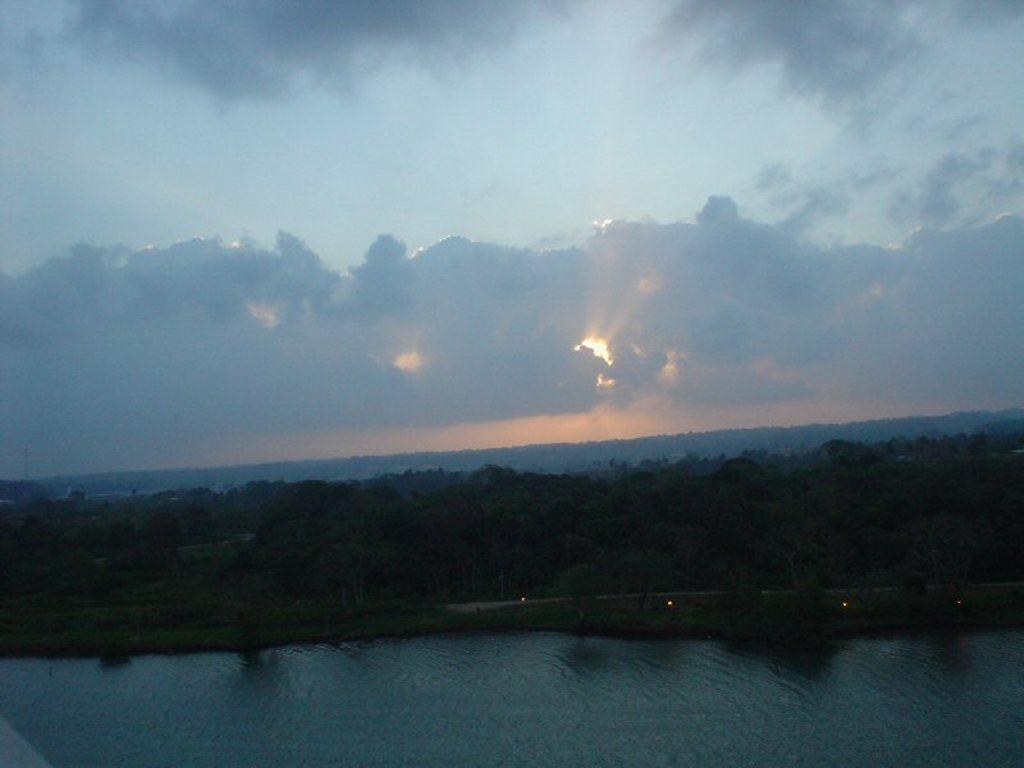What is located at the bottom of the image? There is water at the bottom of the image. What can be seen in the background of the image? There are trees in the background of the image. What is visible at the top of the image? The sky is visible at the top of the image. What can be observed in the sky? Clouds are present in the sky. Where is the mailbox located in the image? There is no mailbox present in the image. What historical event is depicted in the image? There is no historical event depicted in the image; it features water, trees, sky, and clouds. 